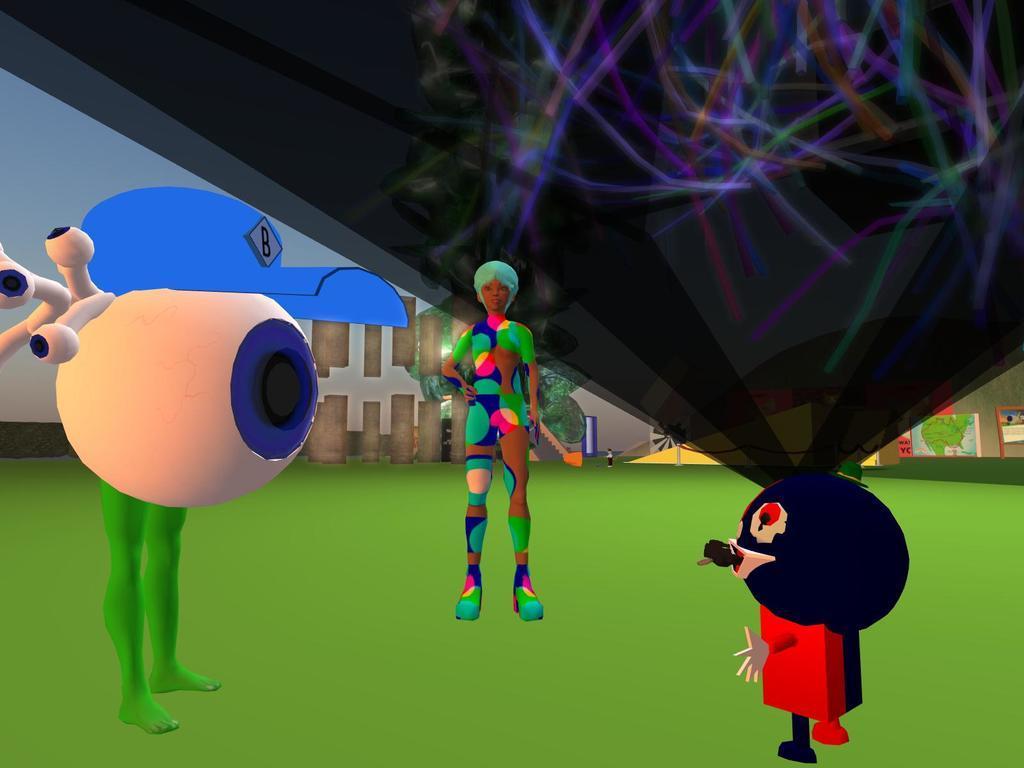Please provide a concise description of this image. This image is an animated image. In the middle there are three toys. At the bottom there is a floor. In the background there is wall. 